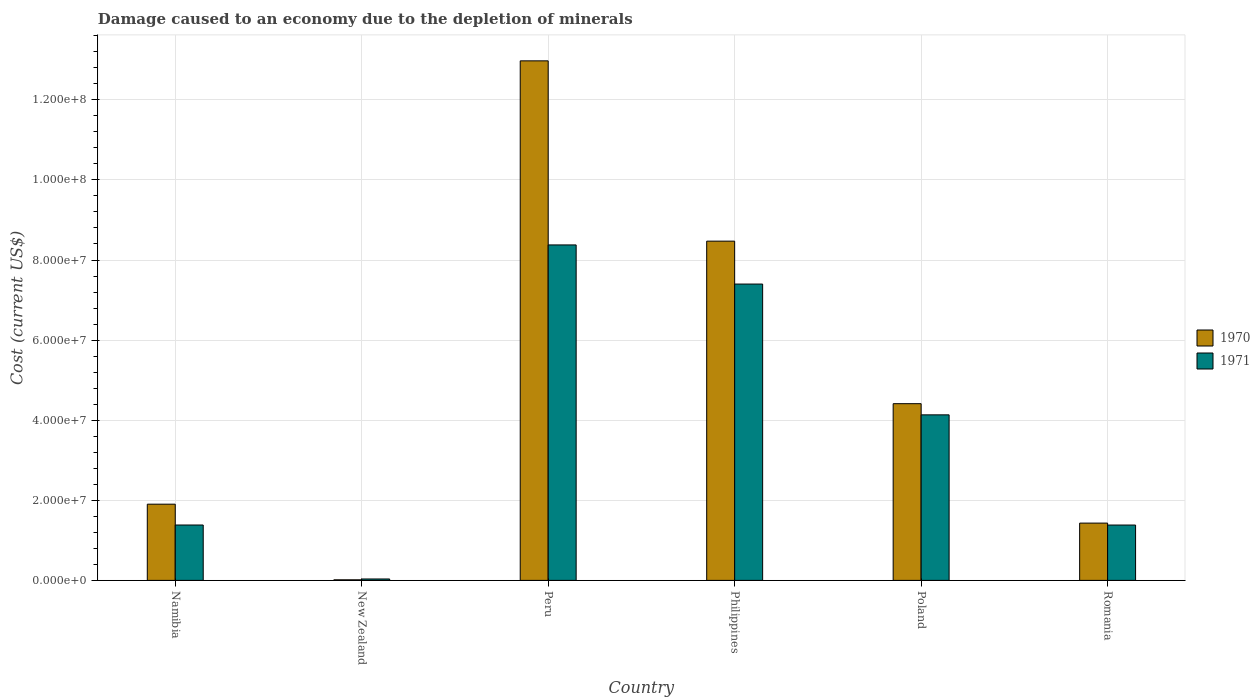How many different coloured bars are there?
Make the answer very short. 2. Are the number of bars per tick equal to the number of legend labels?
Ensure brevity in your answer.  Yes. Are the number of bars on each tick of the X-axis equal?
Provide a succinct answer. Yes. What is the label of the 2nd group of bars from the left?
Provide a short and direct response. New Zealand. What is the cost of damage caused due to the depletion of minerals in 1970 in Romania?
Your answer should be very brief. 1.43e+07. Across all countries, what is the maximum cost of damage caused due to the depletion of minerals in 1971?
Give a very brief answer. 8.38e+07. Across all countries, what is the minimum cost of damage caused due to the depletion of minerals in 1970?
Provide a succinct answer. 1.43e+05. In which country was the cost of damage caused due to the depletion of minerals in 1971 maximum?
Offer a very short reply. Peru. In which country was the cost of damage caused due to the depletion of minerals in 1970 minimum?
Give a very brief answer. New Zealand. What is the total cost of damage caused due to the depletion of minerals in 1970 in the graph?
Provide a short and direct response. 2.92e+08. What is the difference between the cost of damage caused due to the depletion of minerals in 1970 in Namibia and that in Romania?
Your response must be concise. 4.72e+06. What is the difference between the cost of damage caused due to the depletion of minerals in 1971 in Romania and the cost of damage caused due to the depletion of minerals in 1970 in New Zealand?
Provide a succinct answer. 1.37e+07. What is the average cost of damage caused due to the depletion of minerals in 1970 per country?
Offer a very short reply. 4.87e+07. What is the difference between the cost of damage caused due to the depletion of minerals of/in 1970 and cost of damage caused due to the depletion of minerals of/in 1971 in Philippines?
Your answer should be very brief. 1.07e+07. In how many countries, is the cost of damage caused due to the depletion of minerals in 1971 greater than 48000000 US$?
Keep it short and to the point. 2. What is the ratio of the cost of damage caused due to the depletion of minerals in 1970 in Peru to that in Romania?
Your answer should be very brief. 9.07. Is the cost of damage caused due to the depletion of minerals in 1971 in Peru less than that in Philippines?
Your response must be concise. No. Is the difference between the cost of damage caused due to the depletion of minerals in 1970 in Philippines and Romania greater than the difference between the cost of damage caused due to the depletion of minerals in 1971 in Philippines and Romania?
Provide a short and direct response. Yes. What is the difference between the highest and the second highest cost of damage caused due to the depletion of minerals in 1971?
Your response must be concise. 9.77e+06. What is the difference between the highest and the lowest cost of damage caused due to the depletion of minerals in 1971?
Provide a succinct answer. 8.34e+07. What does the 2nd bar from the left in Romania represents?
Provide a succinct answer. 1971. What is the difference between two consecutive major ticks on the Y-axis?
Your answer should be very brief. 2.00e+07. Are the values on the major ticks of Y-axis written in scientific E-notation?
Ensure brevity in your answer.  Yes. Does the graph contain grids?
Offer a terse response. Yes. Where does the legend appear in the graph?
Your answer should be compact. Center right. How many legend labels are there?
Ensure brevity in your answer.  2. How are the legend labels stacked?
Provide a short and direct response. Vertical. What is the title of the graph?
Offer a terse response. Damage caused to an economy due to the depletion of minerals. Does "1981" appear as one of the legend labels in the graph?
Your answer should be compact. No. What is the label or title of the Y-axis?
Offer a very short reply. Cost (current US$). What is the Cost (current US$) of 1970 in Namibia?
Your response must be concise. 1.90e+07. What is the Cost (current US$) of 1971 in Namibia?
Your answer should be very brief. 1.38e+07. What is the Cost (current US$) of 1970 in New Zealand?
Your answer should be compact. 1.43e+05. What is the Cost (current US$) of 1971 in New Zealand?
Offer a very short reply. 3.55e+05. What is the Cost (current US$) in 1970 in Peru?
Your answer should be very brief. 1.30e+08. What is the Cost (current US$) of 1971 in Peru?
Offer a very short reply. 8.38e+07. What is the Cost (current US$) in 1970 in Philippines?
Give a very brief answer. 8.47e+07. What is the Cost (current US$) in 1971 in Philippines?
Offer a terse response. 7.40e+07. What is the Cost (current US$) in 1970 in Poland?
Give a very brief answer. 4.41e+07. What is the Cost (current US$) in 1971 in Poland?
Offer a very short reply. 4.13e+07. What is the Cost (current US$) in 1970 in Romania?
Keep it short and to the point. 1.43e+07. What is the Cost (current US$) in 1971 in Romania?
Provide a succinct answer. 1.38e+07. Across all countries, what is the maximum Cost (current US$) of 1970?
Give a very brief answer. 1.30e+08. Across all countries, what is the maximum Cost (current US$) in 1971?
Your answer should be very brief. 8.38e+07. Across all countries, what is the minimum Cost (current US$) of 1970?
Ensure brevity in your answer.  1.43e+05. Across all countries, what is the minimum Cost (current US$) of 1971?
Your answer should be very brief. 3.55e+05. What is the total Cost (current US$) in 1970 in the graph?
Your answer should be compact. 2.92e+08. What is the total Cost (current US$) in 1971 in the graph?
Ensure brevity in your answer.  2.27e+08. What is the difference between the Cost (current US$) in 1970 in Namibia and that in New Zealand?
Your response must be concise. 1.89e+07. What is the difference between the Cost (current US$) of 1971 in Namibia and that in New Zealand?
Offer a terse response. 1.35e+07. What is the difference between the Cost (current US$) in 1970 in Namibia and that in Peru?
Make the answer very short. -1.11e+08. What is the difference between the Cost (current US$) in 1971 in Namibia and that in Peru?
Offer a terse response. -6.99e+07. What is the difference between the Cost (current US$) of 1970 in Namibia and that in Philippines?
Your answer should be very brief. -6.57e+07. What is the difference between the Cost (current US$) in 1971 in Namibia and that in Philippines?
Ensure brevity in your answer.  -6.02e+07. What is the difference between the Cost (current US$) of 1970 in Namibia and that in Poland?
Provide a short and direct response. -2.51e+07. What is the difference between the Cost (current US$) in 1971 in Namibia and that in Poland?
Provide a succinct answer. -2.75e+07. What is the difference between the Cost (current US$) of 1970 in Namibia and that in Romania?
Offer a terse response. 4.72e+06. What is the difference between the Cost (current US$) in 1971 in Namibia and that in Romania?
Your response must be concise. 9517.83. What is the difference between the Cost (current US$) of 1970 in New Zealand and that in Peru?
Give a very brief answer. -1.30e+08. What is the difference between the Cost (current US$) of 1971 in New Zealand and that in Peru?
Make the answer very short. -8.34e+07. What is the difference between the Cost (current US$) in 1970 in New Zealand and that in Philippines?
Offer a terse response. -8.46e+07. What is the difference between the Cost (current US$) in 1971 in New Zealand and that in Philippines?
Give a very brief answer. -7.36e+07. What is the difference between the Cost (current US$) in 1970 in New Zealand and that in Poland?
Your answer should be very brief. -4.40e+07. What is the difference between the Cost (current US$) of 1971 in New Zealand and that in Poland?
Your answer should be very brief. -4.10e+07. What is the difference between the Cost (current US$) in 1970 in New Zealand and that in Romania?
Offer a terse response. -1.42e+07. What is the difference between the Cost (current US$) in 1971 in New Zealand and that in Romania?
Keep it short and to the point. -1.35e+07. What is the difference between the Cost (current US$) in 1970 in Peru and that in Philippines?
Provide a succinct answer. 4.50e+07. What is the difference between the Cost (current US$) in 1971 in Peru and that in Philippines?
Offer a very short reply. 9.77e+06. What is the difference between the Cost (current US$) in 1970 in Peru and that in Poland?
Make the answer very short. 8.56e+07. What is the difference between the Cost (current US$) in 1971 in Peru and that in Poland?
Offer a terse response. 4.24e+07. What is the difference between the Cost (current US$) of 1970 in Peru and that in Romania?
Keep it short and to the point. 1.15e+08. What is the difference between the Cost (current US$) in 1971 in Peru and that in Romania?
Provide a short and direct response. 6.99e+07. What is the difference between the Cost (current US$) of 1970 in Philippines and that in Poland?
Give a very brief answer. 4.06e+07. What is the difference between the Cost (current US$) in 1971 in Philippines and that in Poland?
Your answer should be compact. 3.27e+07. What is the difference between the Cost (current US$) in 1970 in Philippines and that in Romania?
Provide a short and direct response. 7.04e+07. What is the difference between the Cost (current US$) in 1971 in Philippines and that in Romania?
Your answer should be very brief. 6.02e+07. What is the difference between the Cost (current US$) in 1970 in Poland and that in Romania?
Offer a very short reply. 2.98e+07. What is the difference between the Cost (current US$) of 1971 in Poland and that in Romania?
Offer a very short reply. 2.75e+07. What is the difference between the Cost (current US$) in 1970 in Namibia and the Cost (current US$) in 1971 in New Zealand?
Your answer should be very brief. 1.87e+07. What is the difference between the Cost (current US$) in 1970 in Namibia and the Cost (current US$) in 1971 in Peru?
Your answer should be compact. -6.47e+07. What is the difference between the Cost (current US$) of 1970 in Namibia and the Cost (current US$) of 1971 in Philippines?
Offer a terse response. -5.50e+07. What is the difference between the Cost (current US$) of 1970 in Namibia and the Cost (current US$) of 1971 in Poland?
Give a very brief answer. -2.23e+07. What is the difference between the Cost (current US$) in 1970 in Namibia and the Cost (current US$) in 1971 in Romania?
Your answer should be very brief. 5.21e+06. What is the difference between the Cost (current US$) of 1970 in New Zealand and the Cost (current US$) of 1971 in Peru?
Give a very brief answer. -8.36e+07. What is the difference between the Cost (current US$) in 1970 in New Zealand and the Cost (current US$) in 1971 in Philippines?
Provide a short and direct response. -7.39e+07. What is the difference between the Cost (current US$) in 1970 in New Zealand and the Cost (current US$) in 1971 in Poland?
Provide a succinct answer. -4.12e+07. What is the difference between the Cost (current US$) of 1970 in New Zealand and the Cost (current US$) of 1971 in Romania?
Keep it short and to the point. -1.37e+07. What is the difference between the Cost (current US$) of 1970 in Peru and the Cost (current US$) of 1971 in Philippines?
Provide a succinct answer. 5.57e+07. What is the difference between the Cost (current US$) of 1970 in Peru and the Cost (current US$) of 1971 in Poland?
Your response must be concise. 8.84e+07. What is the difference between the Cost (current US$) of 1970 in Peru and the Cost (current US$) of 1971 in Romania?
Your response must be concise. 1.16e+08. What is the difference between the Cost (current US$) in 1970 in Philippines and the Cost (current US$) in 1971 in Poland?
Your response must be concise. 4.34e+07. What is the difference between the Cost (current US$) of 1970 in Philippines and the Cost (current US$) of 1971 in Romania?
Your answer should be very brief. 7.09e+07. What is the difference between the Cost (current US$) in 1970 in Poland and the Cost (current US$) in 1971 in Romania?
Make the answer very short. 3.03e+07. What is the average Cost (current US$) in 1970 per country?
Keep it short and to the point. 4.87e+07. What is the average Cost (current US$) in 1971 per country?
Your answer should be compact. 3.79e+07. What is the difference between the Cost (current US$) of 1970 and Cost (current US$) of 1971 in Namibia?
Offer a terse response. 5.20e+06. What is the difference between the Cost (current US$) of 1970 and Cost (current US$) of 1971 in New Zealand?
Ensure brevity in your answer.  -2.11e+05. What is the difference between the Cost (current US$) in 1970 and Cost (current US$) in 1971 in Peru?
Offer a very short reply. 4.60e+07. What is the difference between the Cost (current US$) of 1970 and Cost (current US$) of 1971 in Philippines?
Your response must be concise. 1.07e+07. What is the difference between the Cost (current US$) in 1970 and Cost (current US$) in 1971 in Poland?
Offer a terse response. 2.79e+06. What is the difference between the Cost (current US$) in 1970 and Cost (current US$) in 1971 in Romania?
Offer a terse response. 4.85e+05. What is the ratio of the Cost (current US$) of 1970 in Namibia to that in New Zealand?
Provide a succinct answer. 132.75. What is the ratio of the Cost (current US$) in 1971 in Namibia to that in New Zealand?
Keep it short and to the point. 38.97. What is the ratio of the Cost (current US$) in 1970 in Namibia to that in Peru?
Offer a very short reply. 0.15. What is the ratio of the Cost (current US$) in 1971 in Namibia to that in Peru?
Your answer should be very brief. 0.17. What is the ratio of the Cost (current US$) in 1970 in Namibia to that in Philippines?
Offer a very short reply. 0.22. What is the ratio of the Cost (current US$) in 1971 in Namibia to that in Philippines?
Ensure brevity in your answer.  0.19. What is the ratio of the Cost (current US$) of 1970 in Namibia to that in Poland?
Keep it short and to the point. 0.43. What is the ratio of the Cost (current US$) in 1971 in Namibia to that in Poland?
Provide a succinct answer. 0.33. What is the ratio of the Cost (current US$) of 1970 in Namibia to that in Romania?
Provide a succinct answer. 1.33. What is the ratio of the Cost (current US$) of 1970 in New Zealand to that in Peru?
Offer a very short reply. 0. What is the ratio of the Cost (current US$) of 1971 in New Zealand to that in Peru?
Give a very brief answer. 0. What is the ratio of the Cost (current US$) of 1970 in New Zealand to that in Philippines?
Your answer should be compact. 0. What is the ratio of the Cost (current US$) in 1971 in New Zealand to that in Philippines?
Your answer should be very brief. 0. What is the ratio of the Cost (current US$) in 1970 in New Zealand to that in Poland?
Provide a succinct answer. 0. What is the ratio of the Cost (current US$) in 1971 in New Zealand to that in Poland?
Offer a very short reply. 0.01. What is the ratio of the Cost (current US$) of 1971 in New Zealand to that in Romania?
Your response must be concise. 0.03. What is the ratio of the Cost (current US$) in 1970 in Peru to that in Philippines?
Keep it short and to the point. 1.53. What is the ratio of the Cost (current US$) in 1971 in Peru to that in Philippines?
Your answer should be very brief. 1.13. What is the ratio of the Cost (current US$) of 1970 in Peru to that in Poland?
Provide a succinct answer. 2.94. What is the ratio of the Cost (current US$) of 1971 in Peru to that in Poland?
Ensure brevity in your answer.  2.03. What is the ratio of the Cost (current US$) in 1970 in Peru to that in Romania?
Your answer should be compact. 9.07. What is the ratio of the Cost (current US$) in 1971 in Peru to that in Romania?
Offer a terse response. 6.06. What is the ratio of the Cost (current US$) of 1970 in Philippines to that in Poland?
Your answer should be compact. 1.92. What is the ratio of the Cost (current US$) of 1971 in Philippines to that in Poland?
Keep it short and to the point. 1.79. What is the ratio of the Cost (current US$) of 1970 in Philippines to that in Romania?
Offer a terse response. 5.92. What is the ratio of the Cost (current US$) in 1971 in Philippines to that in Romania?
Give a very brief answer. 5.35. What is the ratio of the Cost (current US$) in 1970 in Poland to that in Romania?
Ensure brevity in your answer.  3.08. What is the ratio of the Cost (current US$) of 1971 in Poland to that in Romania?
Ensure brevity in your answer.  2.99. What is the difference between the highest and the second highest Cost (current US$) in 1970?
Your answer should be very brief. 4.50e+07. What is the difference between the highest and the second highest Cost (current US$) of 1971?
Give a very brief answer. 9.77e+06. What is the difference between the highest and the lowest Cost (current US$) in 1970?
Your answer should be very brief. 1.30e+08. What is the difference between the highest and the lowest Cost (current US$) in 1971?
Your response must be concise. 8.34e+07. 